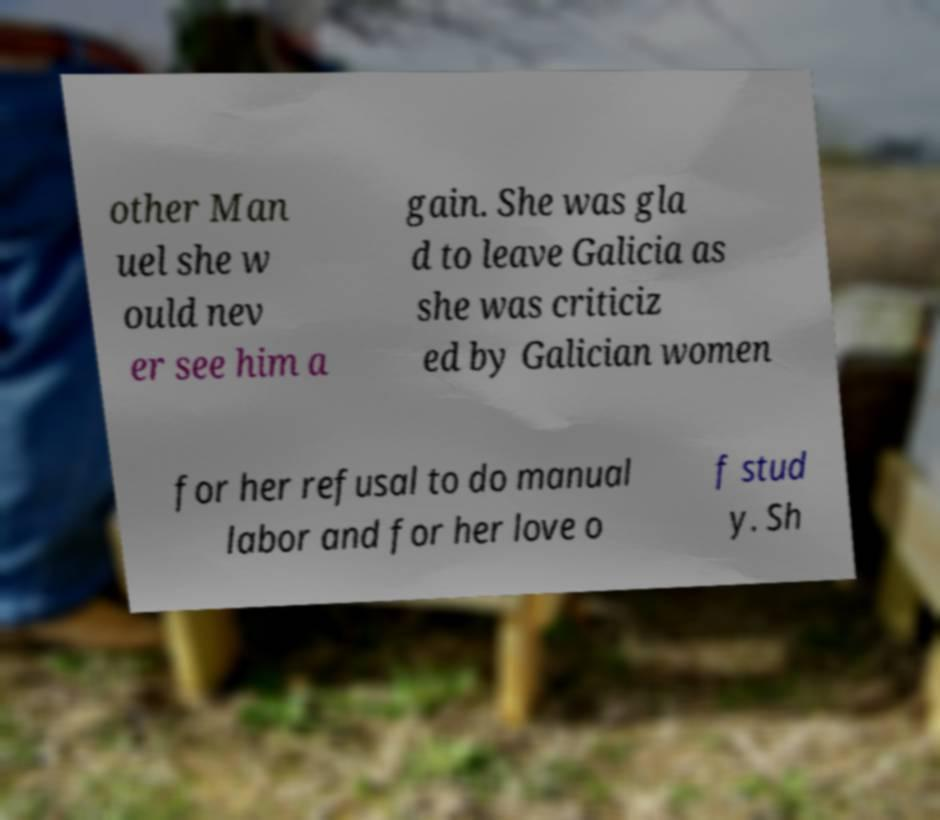I need the written content from this picture converted into text. Can you do that? other Man uel she w ould nev er see him a gain. She was gla d to leave Galicia as she was criticiz ed by Galician women for her refusal to do manual labor and for her love o f stud y. Sh 